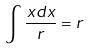<formula> <loc_0><loc_0><loc_500><loc_500>\int \frac { x d x } { r } = r</formula> 